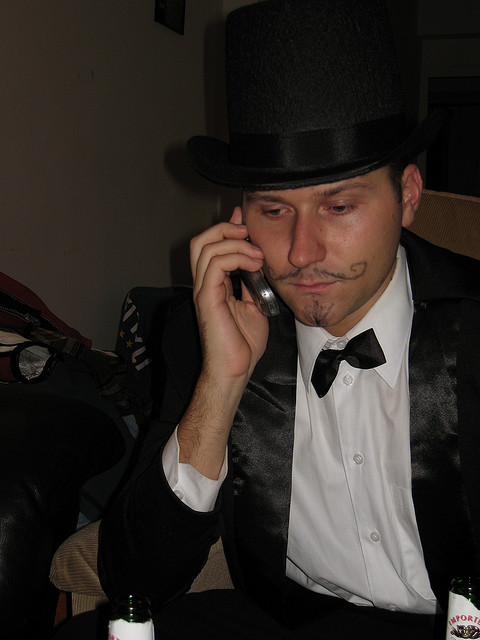Can you describe the mood or atmosphere that the image conveys? The image portrays a solemn or pensive mood, with the person dressed in formal attire and a top hat, holding a phone to their ear with a serious expression. The environment suggests an indoor setting, potentially a personal space where the person is having a significant conversation. 